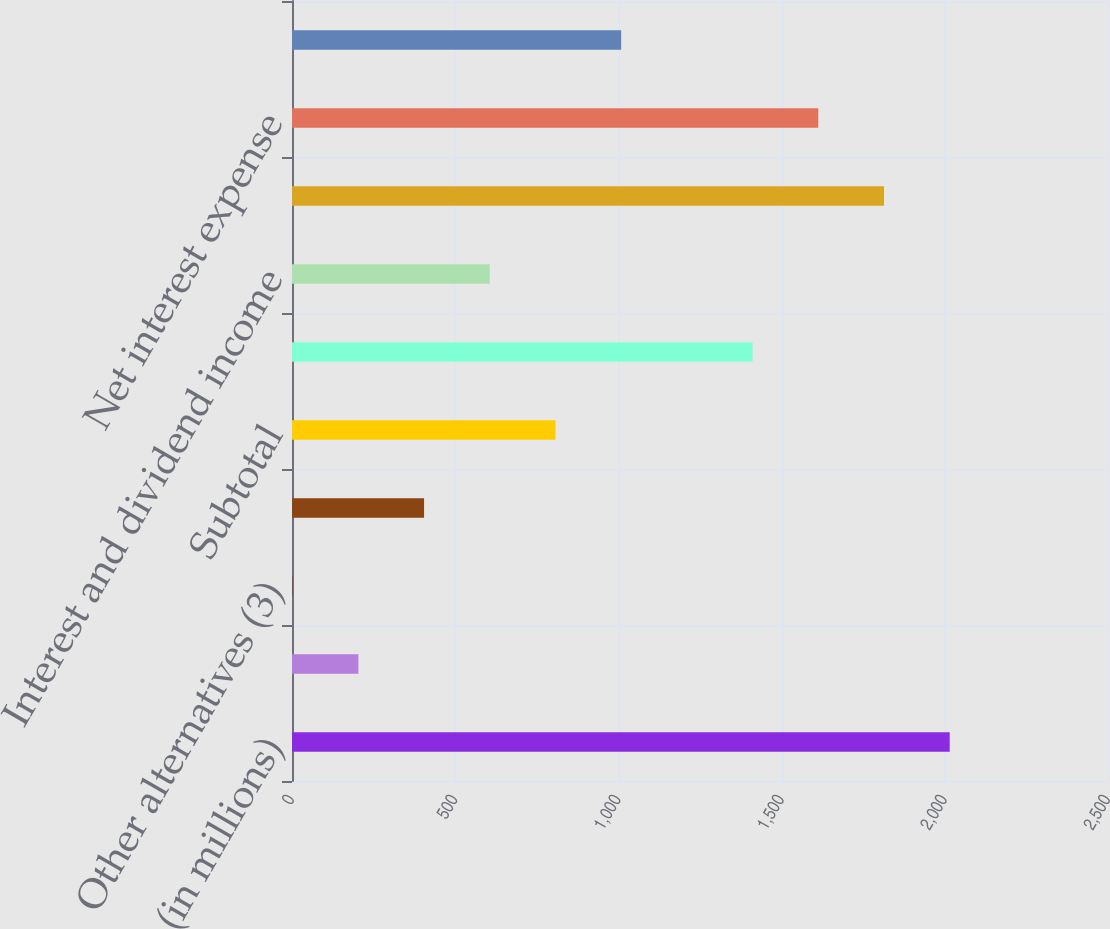<chart> <loc_0><loc_0><loc_500><loc_500><bar_chart><fcel>(in millions)<fcel>Real assets<fcel>Other alternatives (3)<fcel>Other investments (4)<fcel>Subtotal<fcel>Total net gain (loss) on<fcel>Interest and dividend income<fcel>Interest expense<fcel>Net interest expense<fcel>Total nonoperating income<nl><fcel>2015<fcel>203.3<fcel>2<fcel>404.6<fcel>807.2<fcel>1411.1<fcel>605.9<fcel>1813.7<fcel>1612.4<fcel>1008.5<nl></chart> 